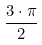<formula> <loc_0><loc_0><loc_500><loc_500>\frac { 3 \cdot \pi } { 2 }</formula> 